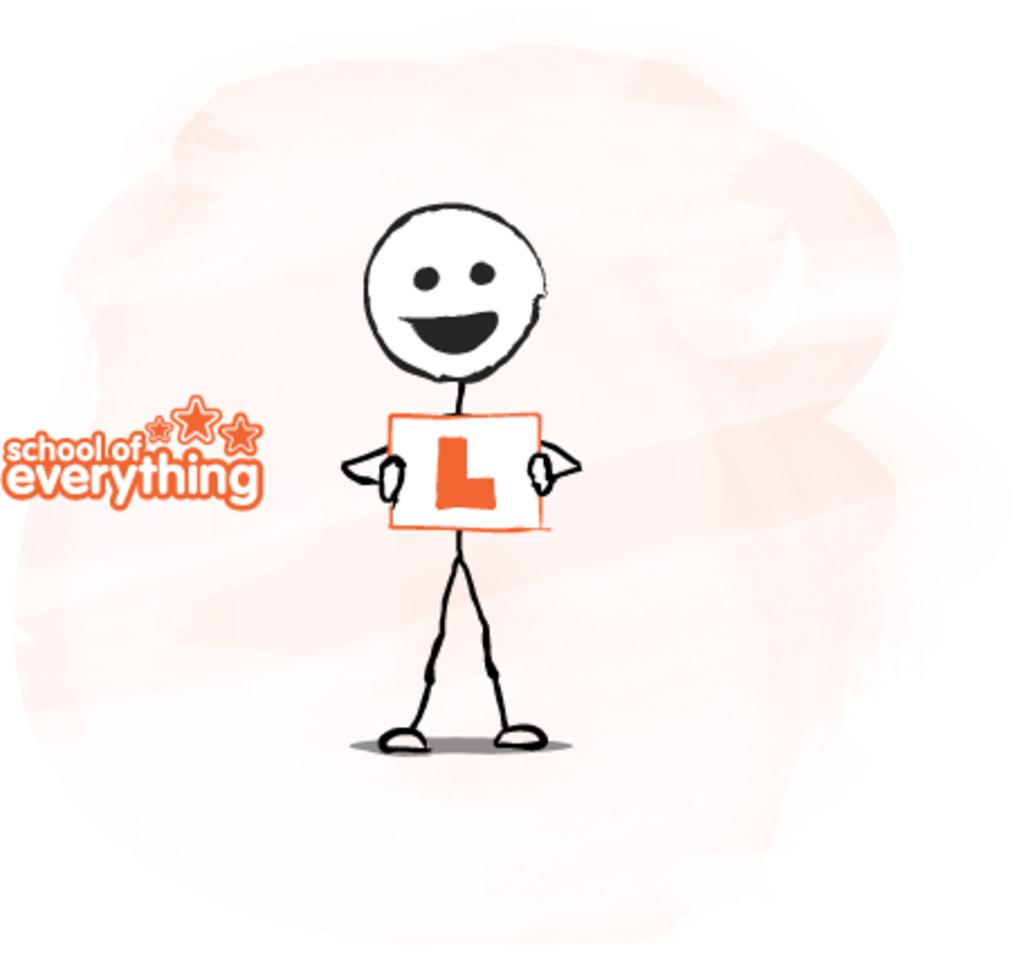What type of image is present in the picture? There is a person clipart in the image. Can you describe any additional features of the person clipart? Yes, there is text on the person clipart. What type of glass is being used by the person in the image? There is no glass present in the image; it features a person clipart with text. What is the person in the image eating for dinner? There is no dinner depicted in the image; it only features a person clipart with text. 